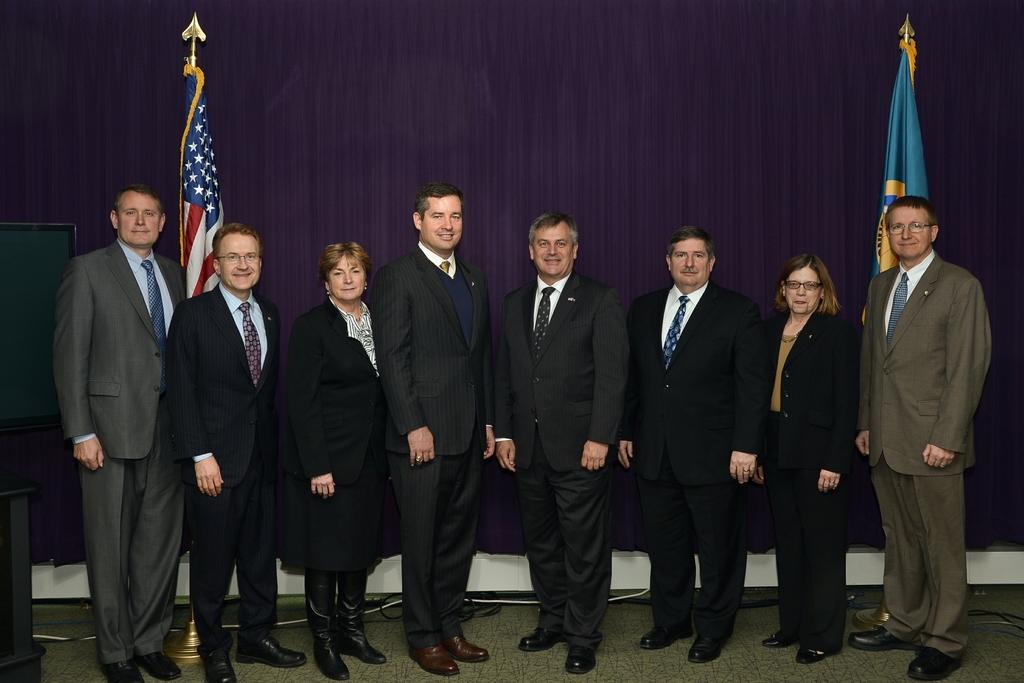In one or two sentences, can you explain what this image depicts? This image contains two women and few men are standing on the floor. Behind them there are few flags and curtain. Men are wearing suit and tie. Women are wearing black jacket. Left side there is a screen. 